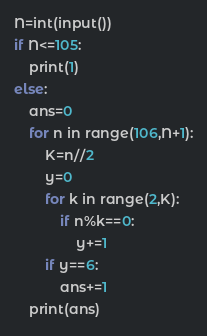<code> <loc_0><loc_0><loc_500><loc_500><_Python_>N=int(input())
if N<=105:
    print(1)
else:
    ans=0
    for n in range(106,N+1):
        K=n//2
        y=0
        for k in range(2,K):
            if n%k==0:
                y+=1
        if y==6:
            ans+=1
    print(ans)</code> 